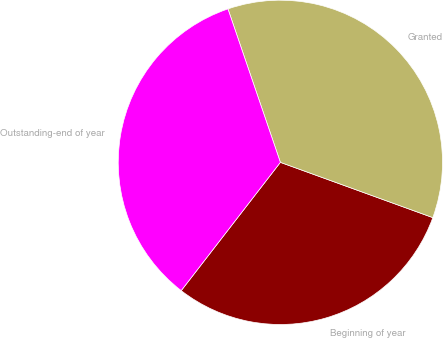Convert chart. <chart><loc_0><loc_0><loc_500><loc_500><pie_chart><fcel>Beginning of year<fcel>Granted<fcel>Outstanding-end of year<nl><fcel>29.94%<fcel>35.78%<fcel>34.29%<nl></chart> 